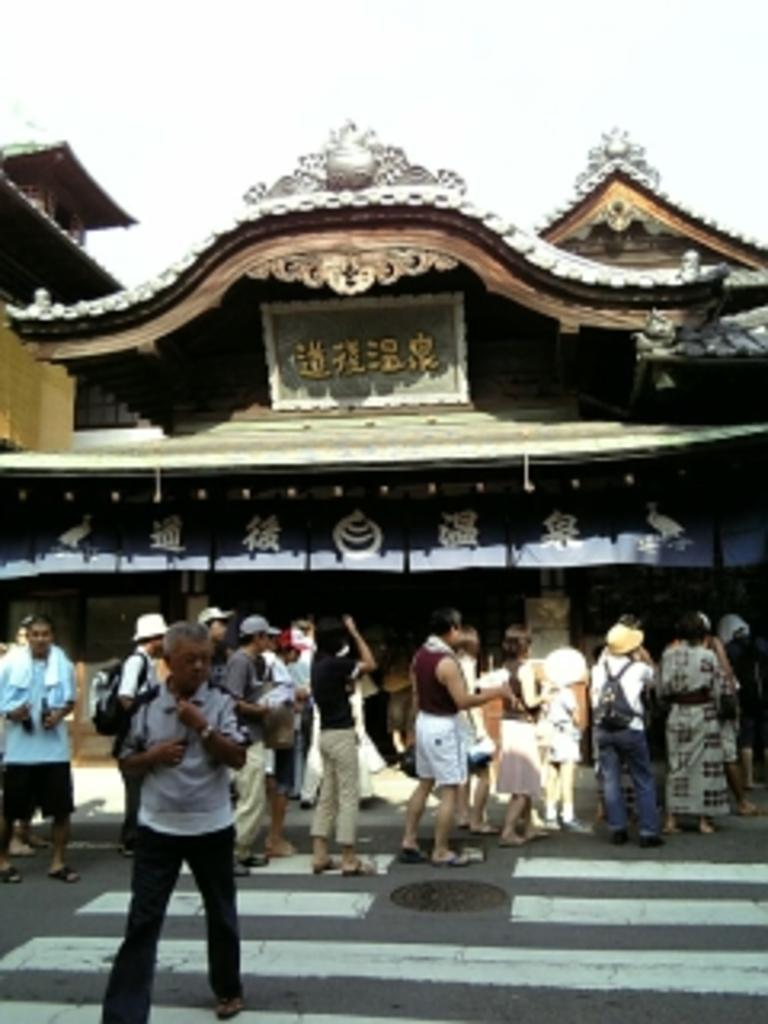What type of structure is shown in the image? The image appears to depict a temple. What is happening in front of the temple? There are people standing on the road in front of the temple. How are the people positioned in relation to each other? The people are standing in a line. What type of cellar can be seen inside the temple in the image? There is no cellar visible in the image, as it depicts a temple and people standing outside. 